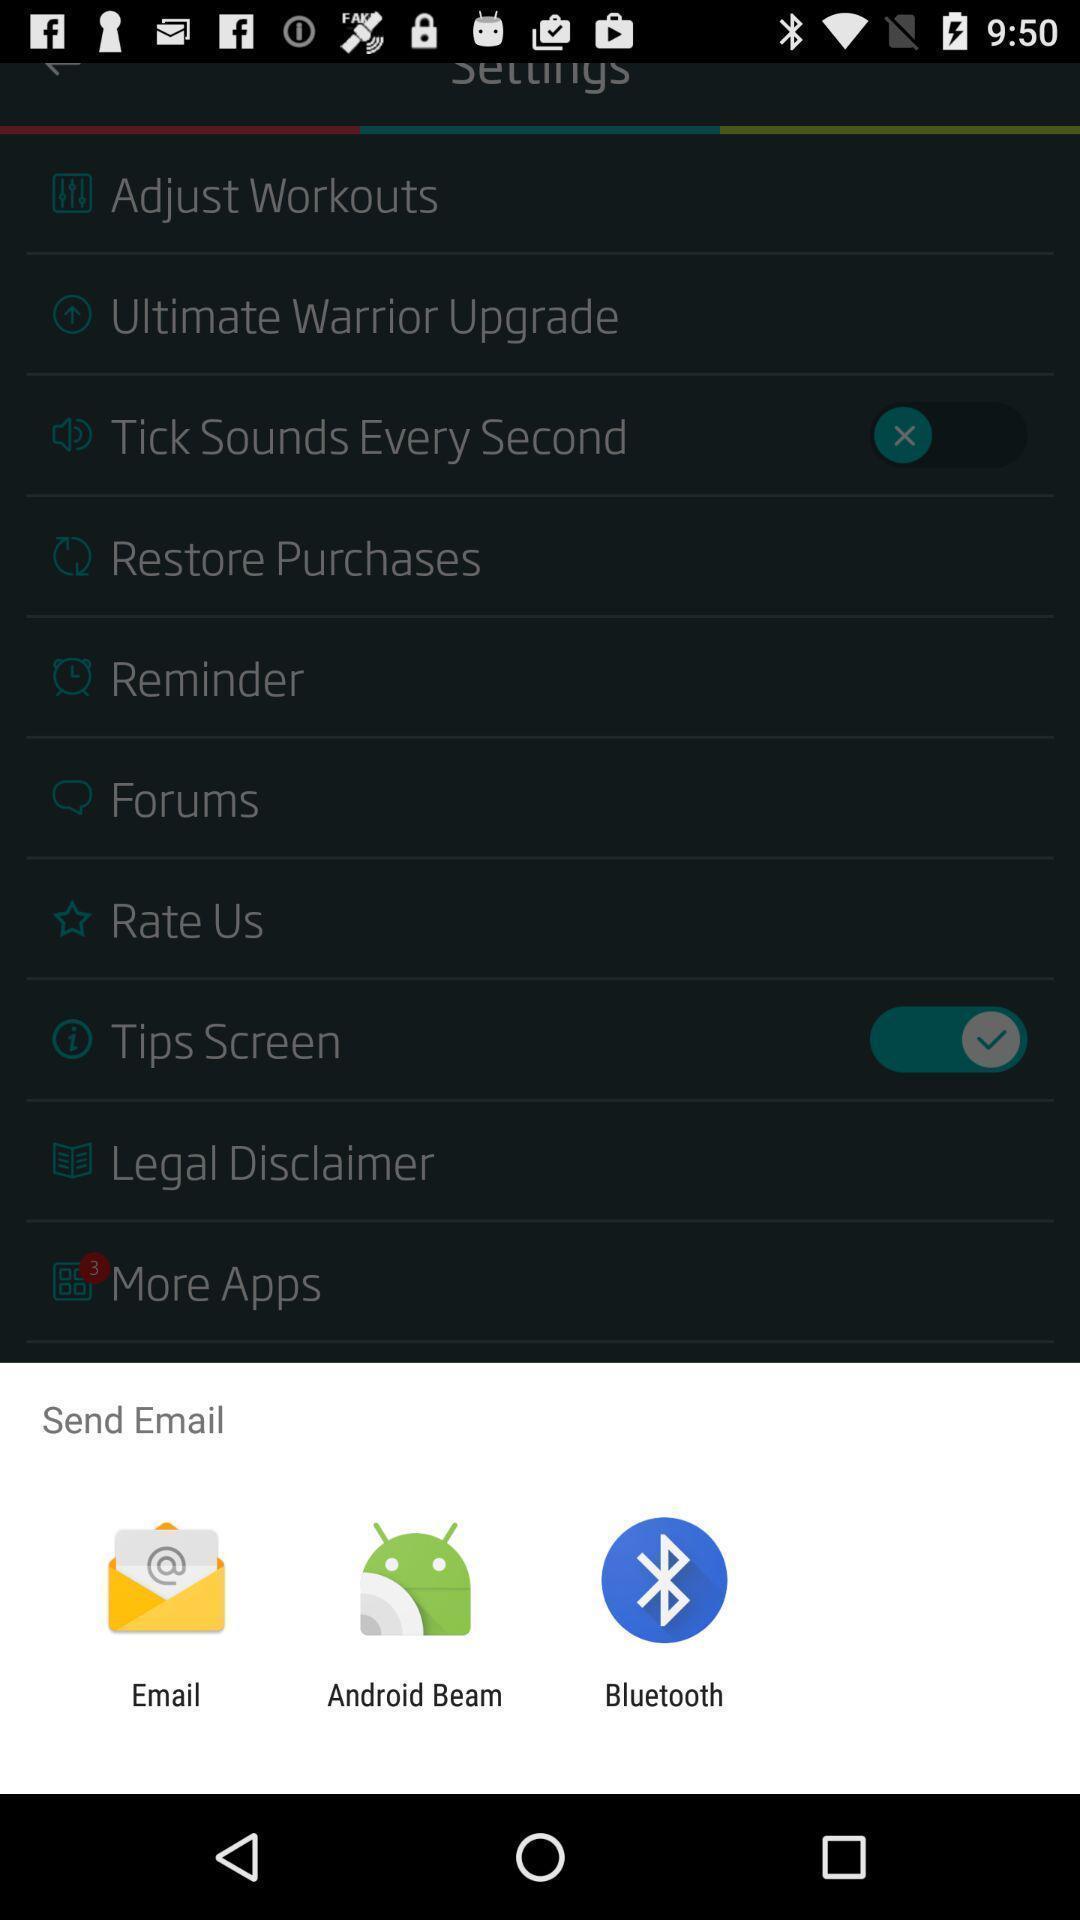Provide a description of this screenshot. Push up message to send mail via other application. 